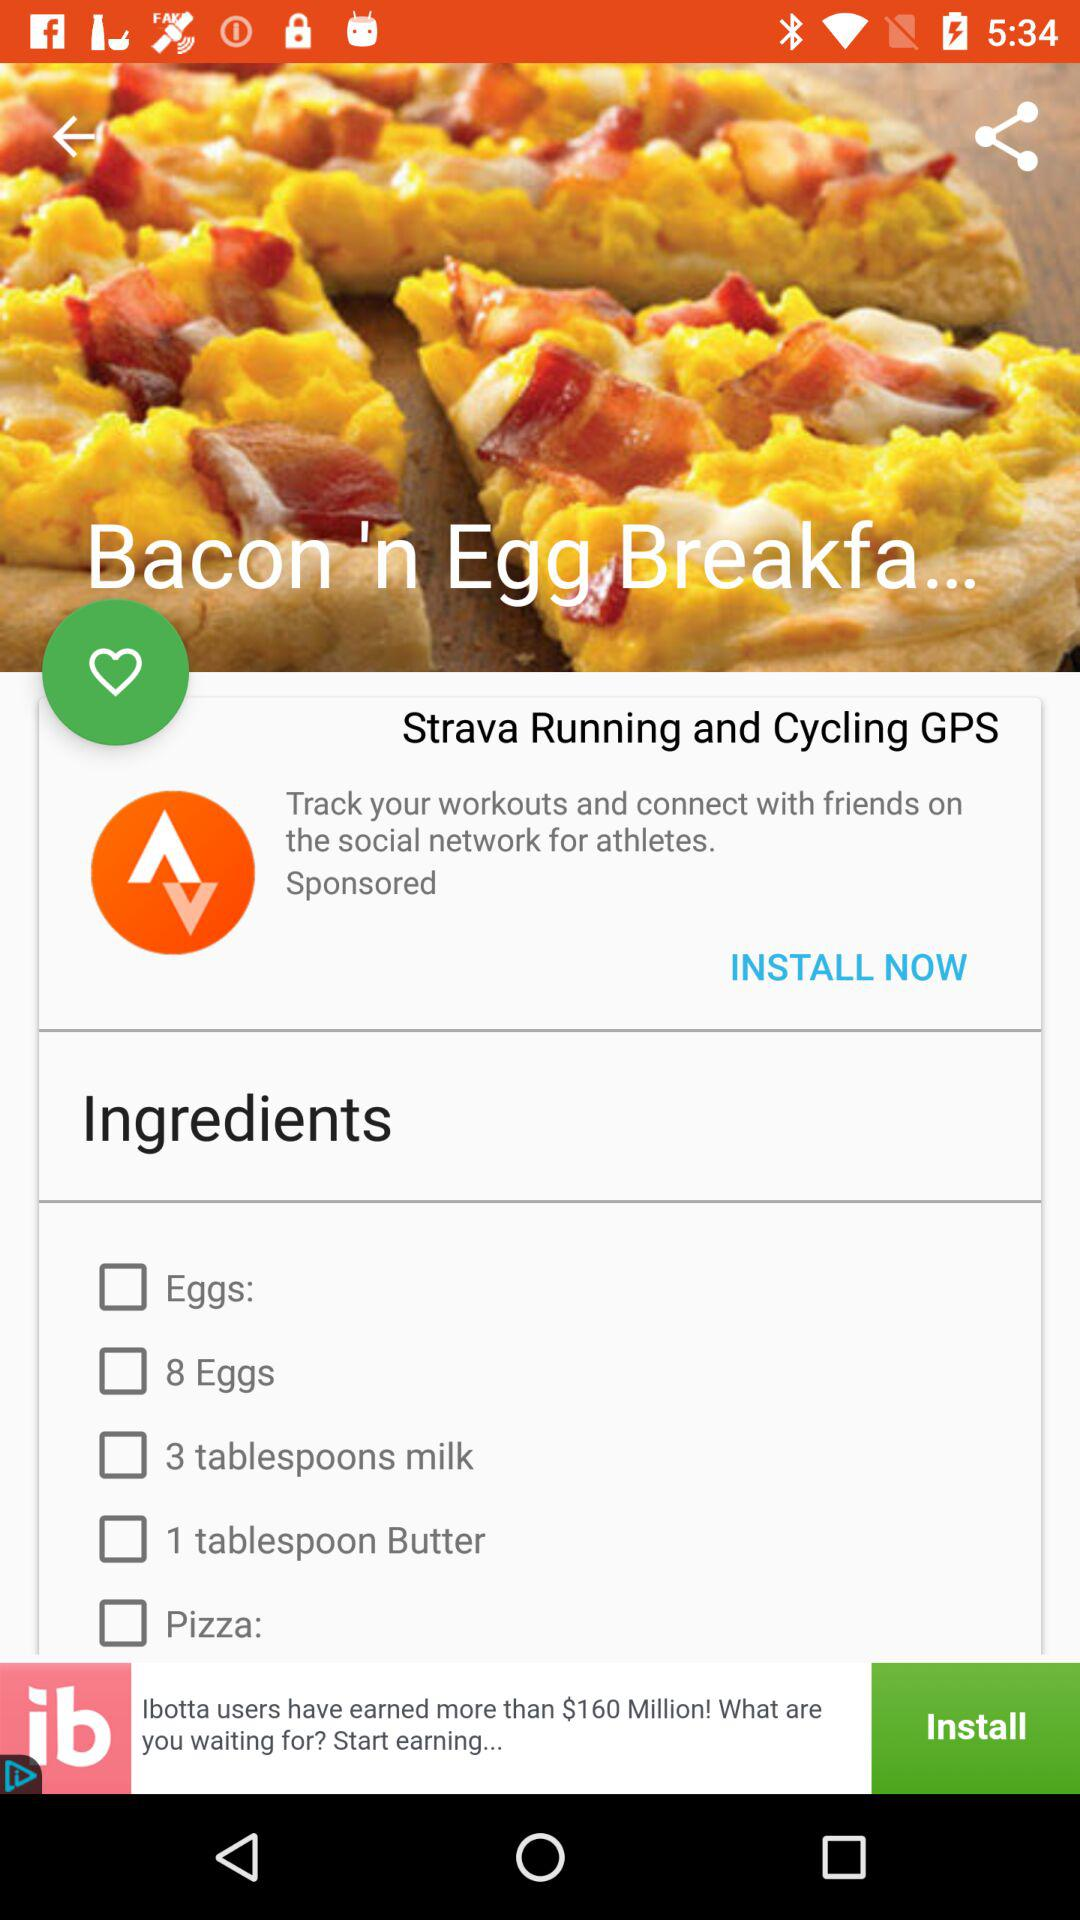How many eggs are needed for the recipe? There are 8 eggs needed for the recipe. 